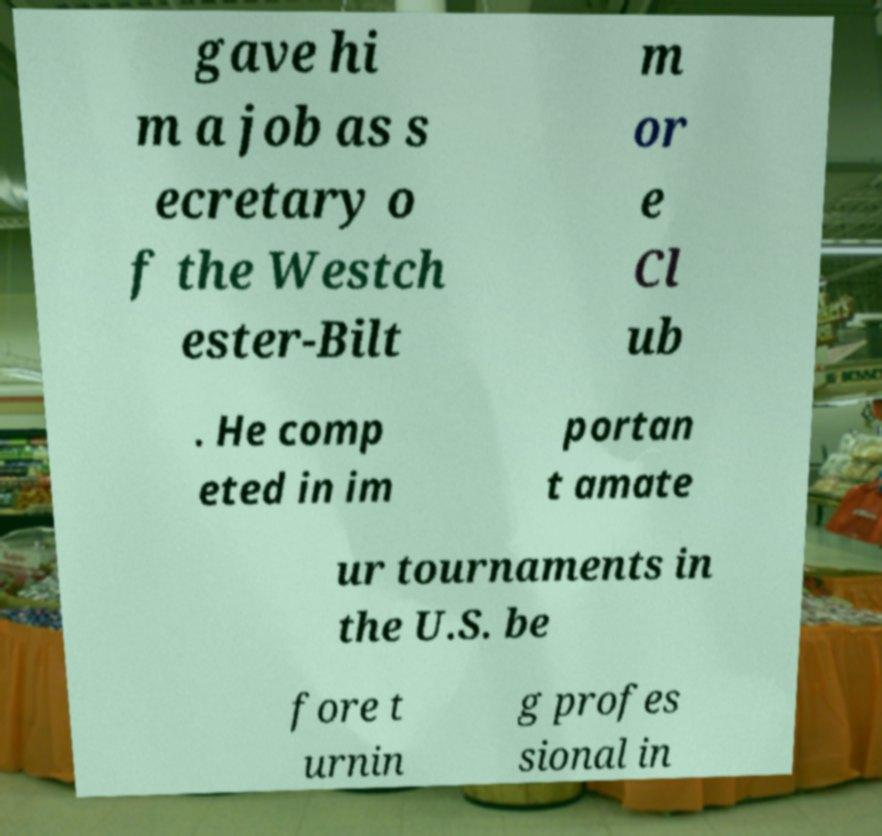Can you accurately transcribe the text from the provided image for me? gave hi m a job as s ecretary o f the Westch ester-Bilt m or e Cl ub . He comp eted in im portan t amate ur tournaments in the U.S. be fore t urnin g profes sional in 